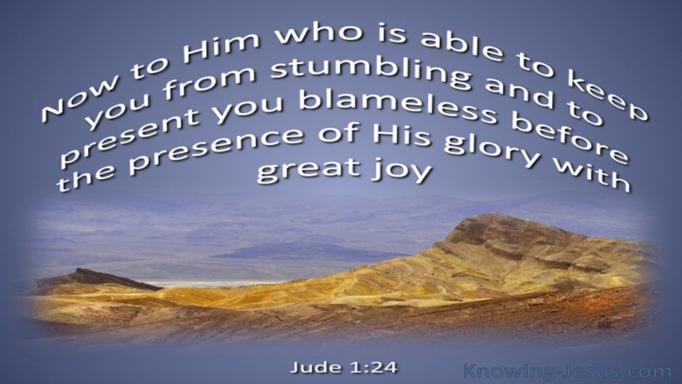What might be the significance of the desert landscape in relation to the verse on the image? The desert landscape in the image can symbolize the spiritual barrenness and challenges that people face in their lives. In the context of Jude 1:24, this setting underscores the message that, despite harsh and desolate conditions, God's protection and guidance are unfailing. It's a visual metaphor for finding divine support even in the most trying circumstances. 